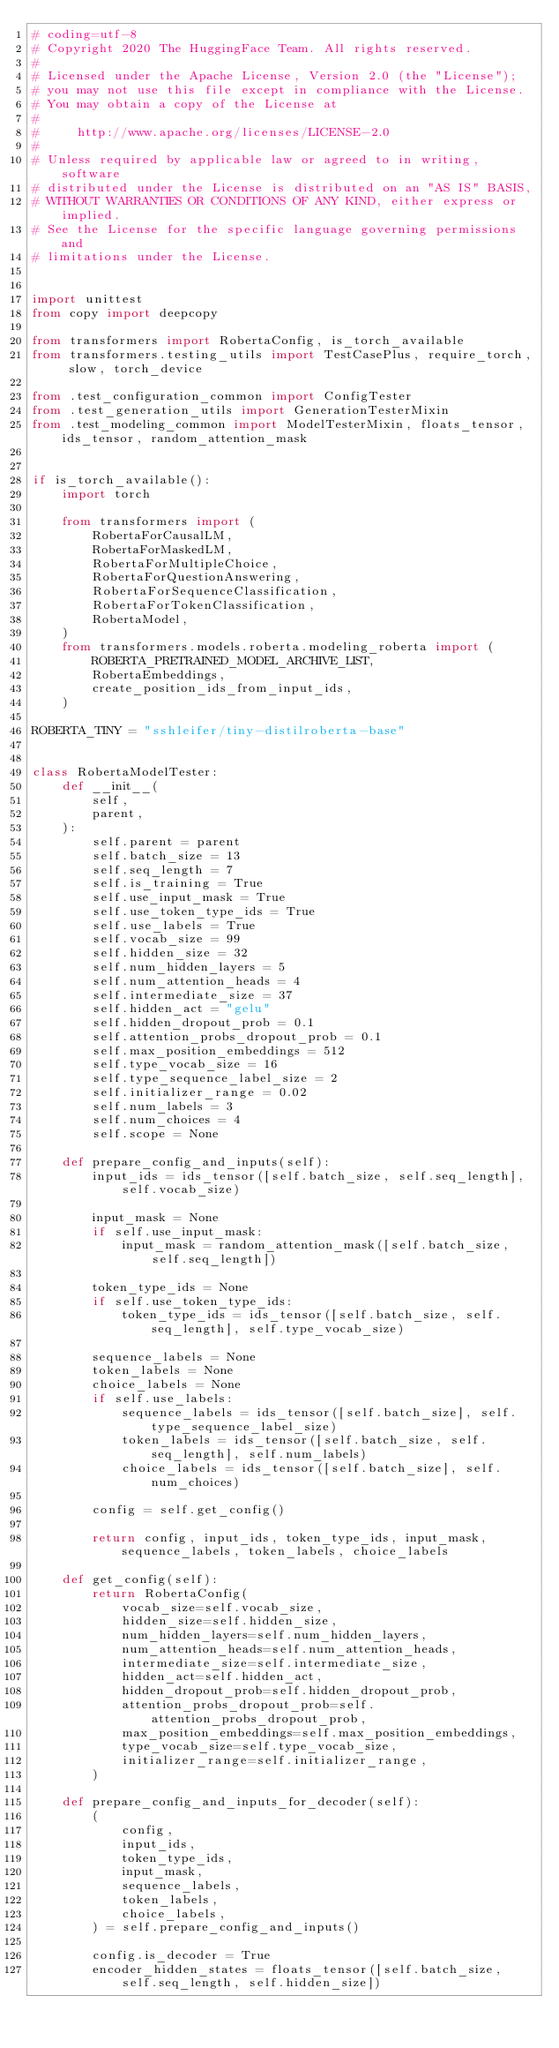<code> <loc_0><loc_0><loc_500><loc_500><_Python_># coding=utf-8
# Copyright 2020 The HuggingFace Team. All rights reserved.
#
# Licensed under the Apache License, Version 2.0 (the "License");
# you may not use this file except in compliance with the License.
# You may obtain a copy of the License at
#
#     http://www.apache.org/licenses/LICENSE-2.0
#
# Unless required by applicable law or agreed to in writing, software
# distributed under the License is distributed on an "AS IS" BASIS,
# WITHOUT WARRANTIES OR CONDITIONS OF ANY KIND, either express or implied.
# See the License for the specific language governing permissions and
# limitations under the License.


import unittest
from copy import deepcopy

from transformers import RobertaConfig, is_torch_available
from transformers.testing_utils import TestCasePlus, require_torch, slow, torch_device

from .test_configuration_common import ConfigTester
from .test_generation_utils import GenerationTesterMixin
from .test_modeling_common import ModelTesterMixin, floats_tensor, ids_tensor, random_attention_mask


if is_torch_available():
    import torch

    from transformers import (
        RobertaForCausalLM,
        RobertaForMaskedLM,
        RobertaForMultipleChoice,
        RobertaForQuestionAnswering,
        RobertaForSequenceClassification,
        RobertaForTokenClassification,
        RobertaModel,
    )
    from transformers.models.roberta.modeling_roberta import (
        ROBERTA_PRETRAINED_MODEL_ARCHIVE_LIST,
        RobertaEmbeddings,
        create_position_ids_from_input_ids,
    )

ROBERTA_TINY = "sshleifer/tiny-distilroberta-base"


class RobertaModelTester:
    def __init__(
        self,
        parent,
    ):
        self.parent = parent
        self.batch_size = 13
        self.seq_length = 7
        self.is_training = True
        self.use_input_mask = True
        self.use_token_type_ids = True
        self.use_labels = True
        self.vocab_size = 99
        self.hidden_size = 32
        self.num_hidden_layers = 5
        self.num_attention_heads = 4
        self.intermediate_size = 37
        self.hidden_act = "gelu"
        self.hidden_dropout_prob = 0.1
        self.attention_probs_dropout_prob = 0.1
        self.max_position_embeddings = 512
        self.type_vocab_size = 16
        self.type_sequence_label_size = 2
        self.initializer_range = 0.02
        self.num_labels = 3
        self.num_choices = 4
        self.scope = None

    def prepare_config_and_inputs(self):
        input_ids = ids_tensor([self.batch_size, self.seq_length], self.vocab_size)

        input_mask = None
        if self.use_input_mask:
            input_mask = random_attention_mask([self.batch_size, self.seq_length])

        token_type_ids = None
        if self.use_token_type_ids:
            token_type_ids = ids_tensor([self.batch_size, self.seq_length], self.type_vocab_size)

        sequence_labels = None
        token_labels = None
        choice_labels = None
        if self.use_labels:
            sequence_labels = ids_tensor([self.batch_size], self.type_sequence_label_size)
            token_labels = ids_tensor([self.batch_size, self.seq_length], self.num_labels)
            choice_labels = ids_tensor([self.batch_size], self.num_choices)

        config = self.get_config()

        return config, input_ids, token_type_ids, input_mask, sequence_labels, token_labels, choice_labels

    def get_config(self):
        return RobertaConfig(
            vocab_size=self.vocab_size,
            hidden_size=self.hidden_size,
            num_hidden_layers=self.num_hidden_layers,
            num_attention_heads=self.num_attention_heads,
            intermediate_size=self.intermediate_size,
            hidden_act=self.hidden_act,
            hidden_dropout_prob=self.hidden_dropout_prob,
            attention_probs_dropout_prob=self.attention_probs_dropout_prob,
            max_position_embeddings=self.max_position_embeddings,
            type_vocab_size=self.type_vocab_size,
            initializer_range=self.initializer_range,
        )

    def prepare_config_and_inputs_for_decoder(self):
        (
            config,
            input_ids,
            token_type_ids,
            input_mask,
            sequence_labels,
            token_labels,
            choice_labels,
        ) = self.prepare_config_and_inputs()

        config.is_decoder = True
        encoder_hidden_states = floats_tensor([self.batch_size, self.seq_length, self.hidden_size])</code> 